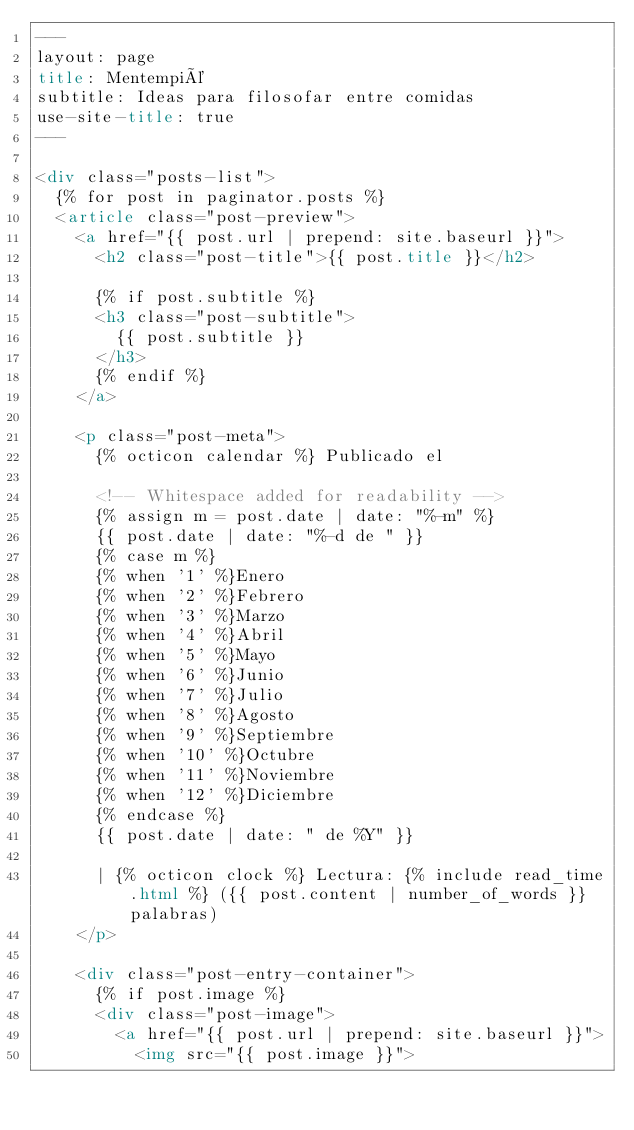Convert code to text. <code><loc_0><loc_0><loc_500><loc_500><_HTML_>---
layout: page
title: Mentempié
subtitle: Ideas para filosofar entre comidas
use-site-title: true
---

<div class="posts-list">
  {% for post in paginator.posts %}
  <article class="post-preview">
    <a href="{{ post.url | prepend: site.baseurl }}">
	  <h2 class="post-title">{{ post.title }}</h2>

	  {% if post.subtitle %}
	  <h3 class="post-subtitle">
	    {{ post.subtitle }}
	  </h3>
	  {% endif %}
    </a>

    <p class="post-meta">
      {% octicon calendar %} Publicado el

      <!-- Whitespace added for readability -->
      {% assign m = post.date | date: "%-m" %}
      {{ post.date | date: "%-d de " }}
      {% case m %}
      {% when '1' %}Enero
      {% when '2' %}Febrero
      {% when '3' %}Marzo
      {% when '4' %}Abril
      {% when '5' %}Mayo
      {% when '6' %}Junio
      {% when '7' %}Julio
      {% when '8' %}Agosto
      {% when '9' %}Septiembre
      {% when '10' %}Octubre
      {% when '11' %}Noviembre
      {% when '12' %}Diciembre
      {% endcase %}
      {{ post.date | date: " de %Y" }} 

      | {% octicon clock %} Lectura: {% include read_time.html %} ({{ post.content | number_of_words }} palabras)
    </p>

    <div class="post-entry-container">
      {% if post.image %}
      <div class="post-image">
        <a href="{{ post.url | prepend: site.baseurl }}">
          <img src="{{ post.image }}"></code> 